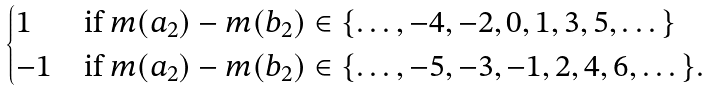<formula> <loc_0><loc_0><loc_500><loc_500>\begin{cases} 1 & \text {if } m ( a _ { 2 } ) - m ( b _ { 2 } ) \in \{ \dots , - 4 , - 2 , 0 , 1 , 3 , 5 , \dots \} \\ - 1 & \text {if } m ( a _ { 2 } ) - m ( b _ { 2 } ) \in \{ \dots , - 5 , - 3 , - 1 , 2 , 4 , 6 , \dots \} . \end{cases}</formula> 